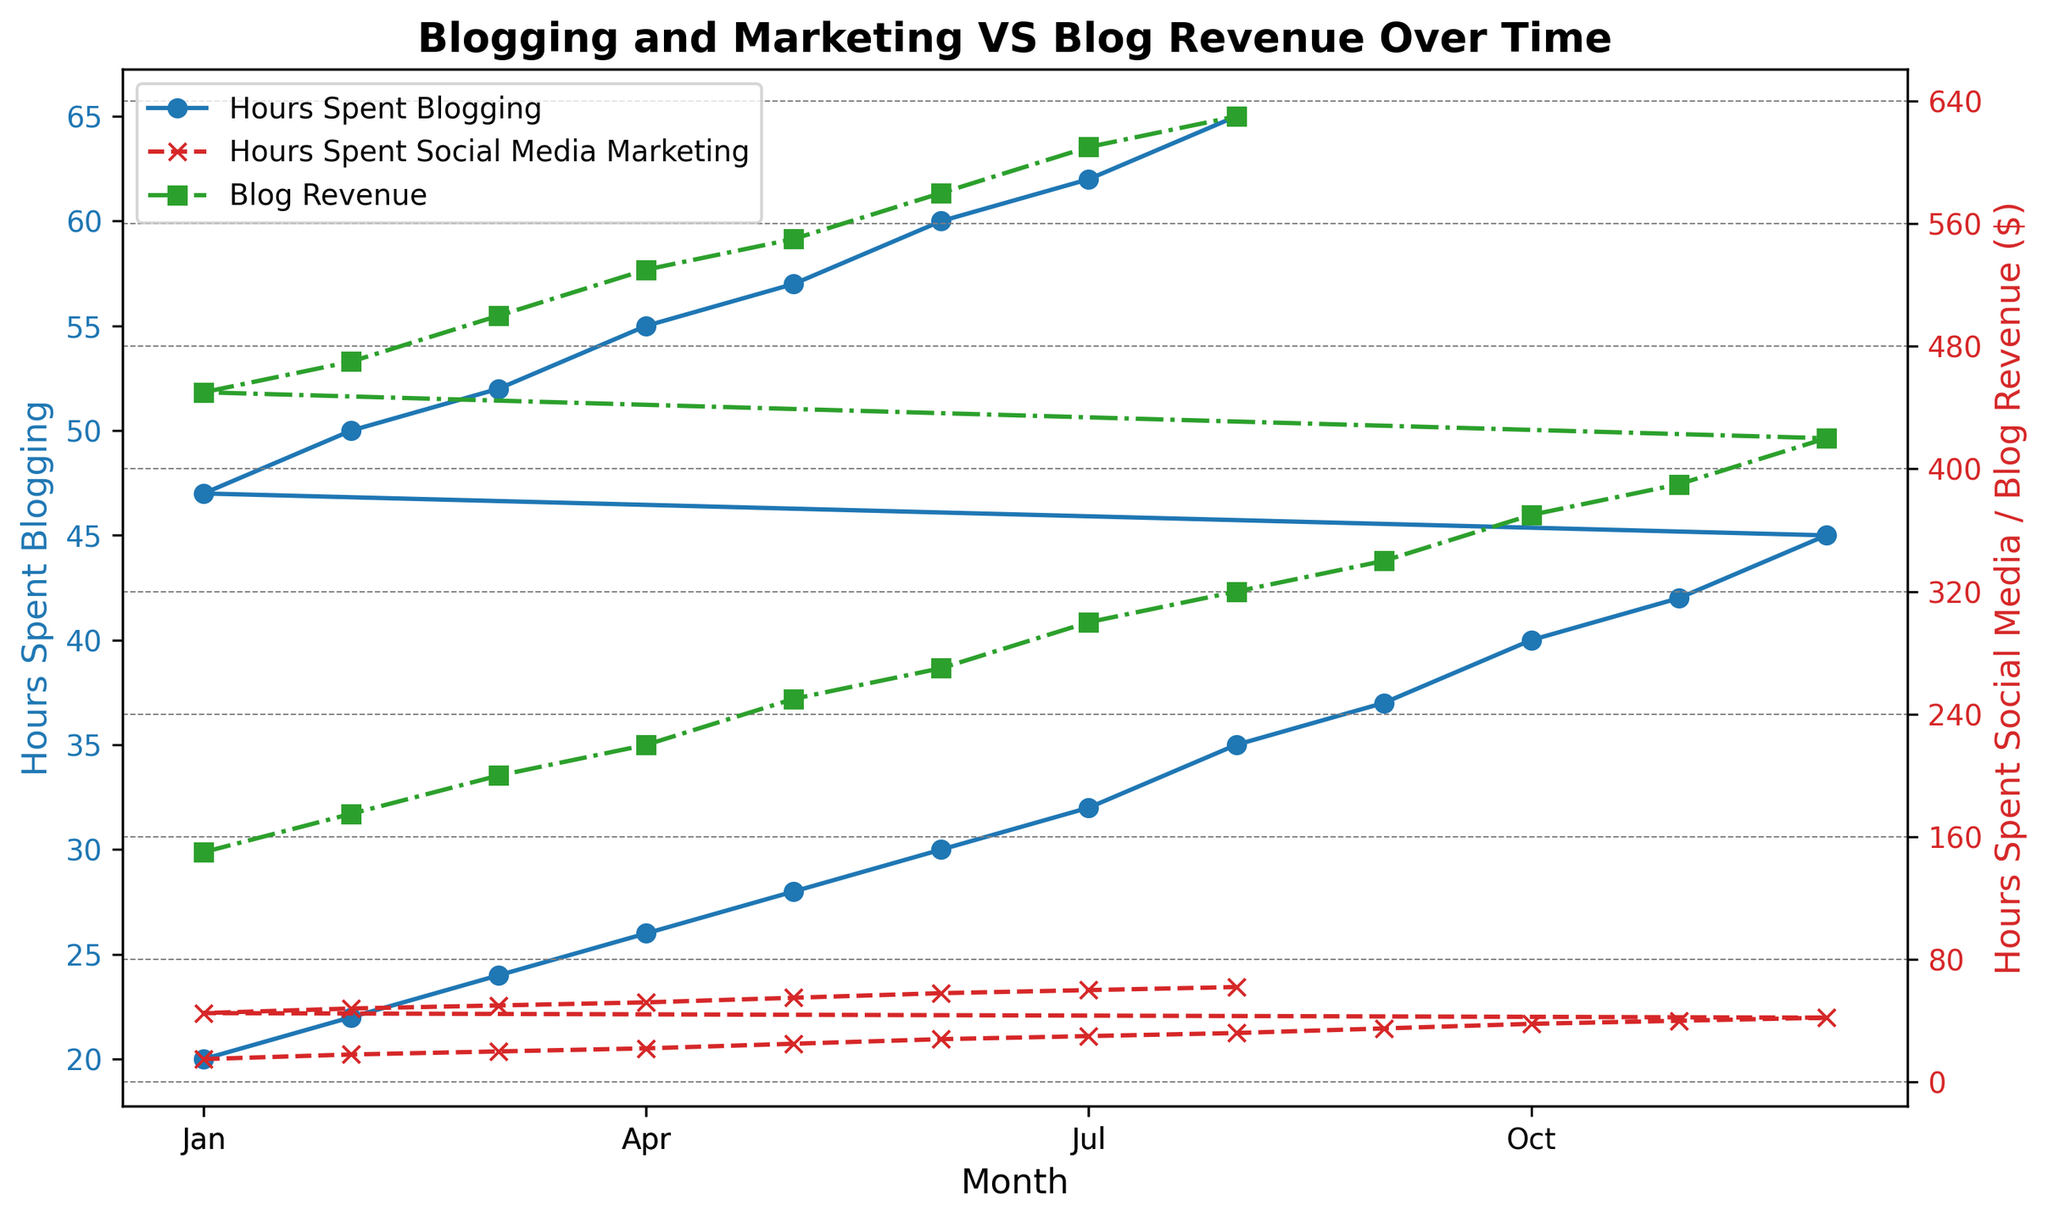What is the overall trend in hours spent blogging over the months? Observing the blue line on the left y-axis, you can see that the hours spent blogging increase steadily from January to August.
Answer: Increasing Which month spent the most hours on social media marketing? Look at the red dashed line with 'x' markers on the right y-axis. The highest point is in August with 62 hours.
Answer: August What is the relationship between hours spent blogging and blog revenue in July? For July, observe that both the blue line (Hours Spent Blogging) and green dashed-dot line with 's' markers (Blog Revenue) are at high points. They correlate closely as the blog's revenue appears to increase with more hours spent blogging.
Answer: They are positively correlated Compare the blog revenue between April and December. Which month had higher revenue and by how much? April's revenue (green dashed-dot line) is at 220, and December's revenue is at 420. Subtract April’s revenue from December’s revenue: 420 - 220 = 200.
Answer: December by 200 In which month did the hours spent on social media marketing exceed 50 but stayed below 55? Look at the red dashed line with 'x' markers on the right y-axis. The period where the hours spent exceed 50 but are below 55 is in May.
Answer: May What is the difference in hours spent blogging between February of the first year and February of the second year? From the blue line: February of the first year shows 22 hours and February of the second year shows 50 hours. The difference is 50 - 22 = 28 hours.
Answer: 28 hours What's the average blog revenue for the months January to June in the first year? The monthly blog revenues from January to June are 150, 175, 200, 220, 250, and 270. Add them together: 150 + 175 + 200 + 220 + 250 + 270 = 1265. Divide by 6: 1265 / 6 = 210.83.
Answer: 210.83 What observations can be made about the relationship between hours spent social media marketing and blog revenue from January to July? Observing the red dashed line and green dashed-dot line, both increase together from January to July. As the hours spent on social media marketing increase, the blog revenue also increases.
Answer: Positive correlation What is the combined total of hours spent blogging and on social media marketing in March? In March, hours spent blogging are 24 and hours spent on social media marketing are 20. Combined total: 24 + 20 = 44.
Answer: 44 hours How does the blog revenue in May compare to the blog revenue in November? Examining the green dashed-dot line with 's' markers, May has revenue of 250 and November has revenue of 390. Hence, November's revenue is higher.
Answer: November's revenue is higher 